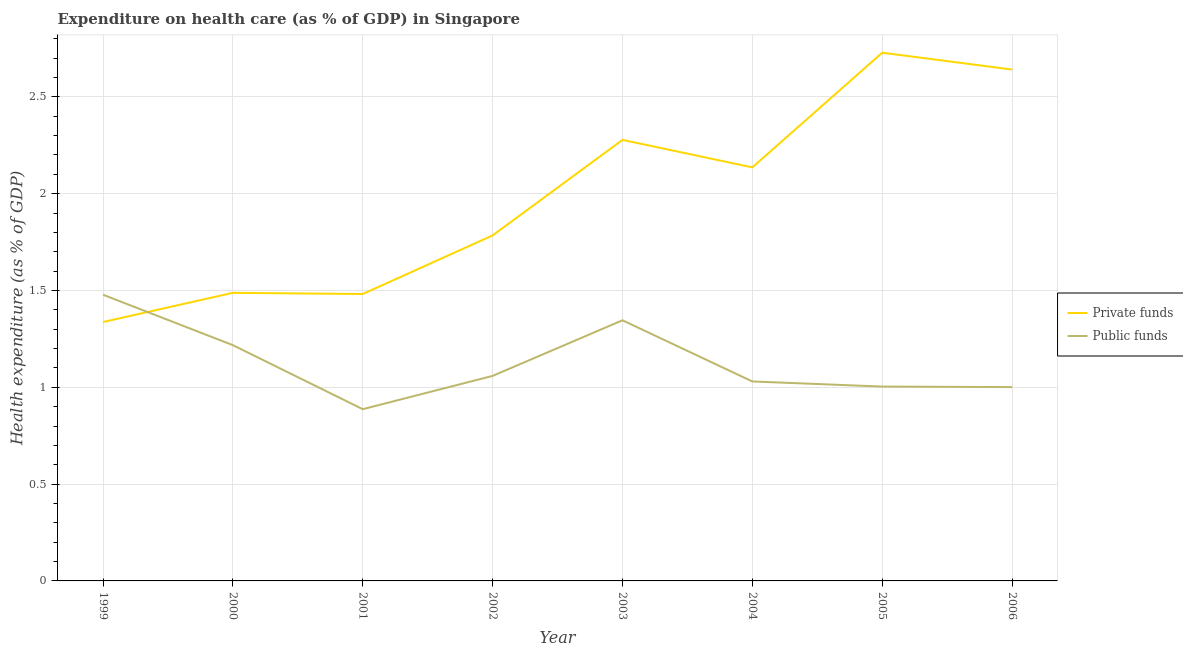How many different coloured lines are there?
Ensure brevity in your answer.  2. What is the amount of private funds spent in healthcare in 2000?
Ensure brevity in your answer.  1.49. Across all years, what is the maximum amount of public funds spent in healthcare?
Ensure brevity in your answer.  1.48. Across all years, what is the minimum amount of private funds spent in healthcare?
Your answer should be compact. 1.34. In which year was the amount of private funds spent in healthcare maximum?
Offer a terse response. 2005. What is the total amount of private funds spent in healthcare in the graph?
Offer a very short reply. 15.87. What is the difference between the amount of private funds spent in healthcare in 2002 and that in 2004?
Offer a terse response. -0.35. What is the difference between the amount of public funds spent in healthcare in 2000 and the amount of private funds spent in healthcare in 2005?
Keep it short and to the point. -1.51. What is the average amount of public funds spent in healthcare per year?
Give a very brief answer. 1.13. In the year 2000, what is the difference between the amount of private funds spent in healthcare and amount of public funds spent in healthcare?
Your answer should be compact. 0.27. In how many years, is the amount of private funds spent in healthcare greater than 2.2 %?
Your response must be concise. 3. What is the ratio of the amount of public funds spent in healthcare in 2000 to that in 2003?
Keep it short and to the point. 0.9. What is the difference between the highest and the second highest amount of private funds spent in healthcare?
Provide a succinct answer. 0.09. What is the difference between the highest and the lowest amount of public funds spent in healthcare?
Provide a short and direct response. 0.59. In how many years, is the amount of private funds spent in healthcare greater than the average amount of private funds spent in healthcare taken over all years?
Provide a short and direct response. 4. Is the sum of the amount of private funds spent in healthcare in 2000 and 2001 greater than the maximum amount of public funds spent in healthcare across all years?
Provide a short and direct response. Yes. Is the amount of public funds spent in healthcare strictly greater than the amount of private funds spent in healthcare over the years?
Keep it short and to the point. No. How many years are there in the graph?
Provide a succinct answer. 8. What is the difference between two consecutive major ticks on the Y-axis?
Your answer should be compact. 0.5. Does the graph contain any zero values?
Keep it short and to the point. No. Where does the legend appear in the graph?
Offer a very short reply. Center right. How many legend labels are there?
Your answer should be very brief. 2. What is the title of the graph?
Provide a short and direct response. Expenditure on health care (as % of GDP) in Singapore. Does "Crop" appear as one of the legend labels in the graph?
Ensure brevity in your answer.  No. What is the label or title of the Y-axis?
Give a very brief answer. Health expenditure (as % of GDP). What is the Health expenditure (as % of GDP) in Private funds in 1999?
Keep it short and to the point. 1.34. What is the Health expenditure (as % of GDP) of Public funds in 1999?
Your response must be concise. 1.48. What is the Health expenditure (as % of GDP) in Private funds in 2000?
Your answer should be very brief. 1.49. What is the Health expenditure (as % of GDP) of Public funds in 2000?
Make the answer very short. 1.22. What is the Health expenditure (as % of GDP) in Private funds in 2001?
Your answer should be very brief. 1.48. What is the Health expenditure (as % of GDP) in Public funds in 2001?
Give a very brief answer. 0.89. What is the Health expenditure (as % of GDP) in Private funds in 2002?
Make the answer very short. 1.78. What is the Health expenditure (as % of GDP) in Public funds in 2002?
Your answer should be very brief. 1.06. What is the Health expenditure (as % of GDP) in Private funds in 2003?
Give a very brief answer. 2.28. What is the Health expenditure (as % of GDP) in Public funds in 2003?
Provide a short and direct response. 1.35. What is the Health expenditure (as % of GDP) of Private funds in 2004?
Keep it short and to the point. 2.14. What is the Health expenditure (as % of GDP) of Public funds in 2004?
Your response must be concise. 1.03. What is the Health expenditure (as % of GDP) in Private funds in 2005?
Your answer should be very brief. 2.73. What is the Health expenditure (as % of GDP) of Public funds in 2005?
Your answer should be compact. 1. What is the Health expenditure (as % of GDP) in Private funds in 2006?
Offer a very short reply. 2.64. What is the Health expenditure (as % of GDP) in Public funds in 2006?
Offer a terse response. 1. Across all years, what is the maximum Health expenditure (as % of GDP) in Private funds?
Provide a short and direct response. 2.73. Across all years, what is the maximum Health expenditure (as % of GDP) of Public funds?
Your answer should be compact. 1.48. Across all years, what is the minimum Health expenditure (as % of GDP) in Private funds?
Keep it short and to the point. 1.34. Across all years, what is the minimum Health expenditure (as % of GDP) in Public funds?
Make the answer very short. 0.89. What is the total Health expenditure (as % of GDP) of Private funds in the graph?
Your answer should be very brief. 15.87. What is the total Health expenditure (as % of GDP) of Public funds in the graph?
Your answer should be very brief. 9.02. What is the difference between the Health expenditure (as % of GDP) of Private funds in 1999 and that in 2000?
Your response must be concise. -0.15. What is the difference between the Health expenditure (as % of GDP) in Public funds in 1999 and that in 2000?
Keep it short and to the point. 0.26. What is the difference between the Health expenditure (as % of GDP) of Private funds in 1999 and that in 2001?
Provide a succinct answer. -0.14. What is the difference between the Health expenditure (as % of GDP) in Public funds in 1999 and that in 2001?
Provide a short and direct response. 0.59. What is the difference between the Health expenditure (as % of GDP) of Private funds in 1999 and that in 2002?
Your response must be concise. -0.45. What is the difference between the Health expenditure (as % of GDP) of Public funds in 1999 and that in 2002?
Keep it short and to the point. 0.42. What is the difference between the Health expenditure (as % of GDP) in Private funds in 1999 and that in 2003?
Provide a short and direct response. -0.94. What is the difference between the Health expenditure (as % of GDP) in Public funds in 1999 and that in 2003?
Ensure brevity in your answer.  0.13. What is the difference between the Health expenditure (as % of GDP) in Private funds in 1999 and that in 2004?
Provide a short and direct response. -0.8. What is the difference between the Health expenditure (as % of GDP) in Public funds in 1999 and that in 2004?
Keep it short and to the point. 0.45. What is the difference between the Health expenditure (as % of GDP) of Private funds in 1999 and that in 2005?
Provide a succinct answer. -1.39. What is the difference between the Health expenditure (as % of GDP) in Public funds in 1999 and that in 2005?
Make the answer very short. 0.47. What is the difference between the Health expenditure (as % of GDP) of Private funds in 1999 and that in 2006?
Your answer should be compact. -1.3. What is the difference between the Health expenditure (as % of GDP) of Public funds in 1999 and that in 2006?
Provide a succinct answer. 0.48. What is the difference between the Health expenditure (as % of GDP) in Private funds in 2000 and that in 2001?
Provide a succinct answer. 0.01. What is the difference between the Health expenditure (as % of GDP) in Public funds in 2000 and that in 2001?
Provide a short and direct response. 0.33. What is the difference between the Health expenditure (as % of GDP) of Private funds in 2000 and that in 2002?
Offer a terse response. -0.3. What is the difference between the Health expenditure (as % of GDP) of Public funds in 2000 and that in 2002?
Offer a very short reply. 0.16. What is the difference between the Health expenditure (as % of GDP) of Private funds in 2000 and that in 2003?
Your answer should be very brief. -0.79. What is the difference between the Health expenditure (as % of GDP) of Public funds in 2000 and that in 2003?
Make the answer very short. -0.13. What is the difference between the Health expenditure (as % of GDP) of Private funds in 2000 and that in 2004?
Ensure brevity in your answer.  -0.65. What is the difference between the Health expenditure (as % of GDP) in Public funds in 2000 and that in 2004?
Your response must be concise. 0.19. What is the difference between the Health expenditure (as % of GDP) of Private funds in 2000 and that in 2005?
Give a very brief answer. -1.24. What is the difference between the Health expenditure (as % of GDP) in Public funds in 2000 and that in 2005?
Ensure brevity in your answer.  0.21. What is the difference between the Health expenditure (as % of GDP) in Private funds in 2000 and that in 2006?
Ensure brevity in your answer.  -1.15. What is the difference between the Health expenditure (as % of GDP) of Public funds in 2000 and that in 2006?
Your answer should be very brief. 0.22. What is the difference between the Health expenditure (as % of GDP) of Private funds in 2001 and that in 2002?
Provide a short and direct response. -0.3. What is the difference between the Health expenditure (as % of GDP) of Public funds in 2001 and that in 2002?
Provide a succinct answer. -0.17. What is the difference between the Health expenditure (as % of GDP) of Private funds in 2001 and that in 2003?
Your answer should be compact. -0.8. What is the difference between the Health expenditure (as % of GDP) in Public funds in 2001 and that in 2003?
Offer a very short reply. -0.46. What is the difference between the Health expenditure (as % of GDP) of Private funds in 2001 and that in 2004?
Your response must be concise. -0.65. What is the difference between the Health expenditure (as % of GDP) in Public funds in 2001 and that in 2004?
Give a very brief answer. -0.14. What is the difference between the Health expenditure (as % of GDP) of Private funds in 2001 and that in 2005?
Provide a short and direct response. -1.25. What is the difference between the Health expenditure (as % of GDP) in Public funds in 2001 and that in 2005?
Offer a very short reply. -0.12. What is the difference between the Health expenditure (as % of GDP) of Private funds in 2001 and that in 2006?
Your answer should be compact. -1.16. What is the difference between the Health expenditure (as % of GDP) in Public funds in 2001 and that in 2006?
Keep it short and to the point. -0.11. What is the difference between the Health expenditure (as % of GDP) of Private funds in 2002 and that in 2003?
Provide a short and direct response. -0.49. What is the difference between the Health expenditure (as % of GDP) of Public funds in 2002 and that in 2003?
Your answer should be compact. -0.29. What is the difference between the Health expenditure (as % of GDP) in Private funds in 2002 and that in 2004?
Your answer should be compact. -0.35. What is the difference between the Health expenditure (as % of GDP) in Public funds in 2002 and that in 2004?
Give a very brief answer. 0.03. What is the difference between the Health expenditure (as % of GDP) of Private funds in 2002 and that in 2005?
Provide a short and direct response. -0.94. What is the difference between the Health expenditure (as % of GDP) in Public funds in 2002 and that in 2005?
Offer a very short reply. 0.06. What is the difference between the Health expenditure (as % of GDP) in Private funds in 2002 and that in 2006?
Your answer should be compact. -0.86. What is the difference between the Health expenditure (as % of GDP) in Public funds in 2002 and that in 2006?
Offer a very short reply. 0.06. What is the difference between the Health expenditure (as % of GDP) of Private funds in 2003 and that in 2004?
Provide a succinct answer. 0.14. What is the difference between the Health expenditure (as % of GDP) in Public funds in 2003 and that in 2004?
Provide a short and direct response. 0.32. What is the difference between the Health expenditure (as % of GDP) in Private funds in 2003 and that in 2005?
Your answer should be very brief. -0.45. What is the difference between the Health expenditure (as % of GDP) of Public funds in 2003 and that in 2005?
Your answer should be very brief. 0.34. What is the difference between the Health expenditure (as % of GDP) of Private funds in 2003 and that in 2006?
Keep it short and to the point. -0.36. What is the difference between the Health expenditure (as % of GDP) in Public funds in 2003 and that in 2006?
Offer a terse response. 0.35. What is the difference between the Health expenditure (as % of GDP) in Private funds in 2004 and that in 2005?
Provide a succinct answer. -0.59. What is the difference between the Health expenditure (as % of GDP) of Public funds in 2004 and that in 2005?
Ensure brevity in your answer.  0.03. What is the difference between the Health expenditure (as % of GDP) of Private funds in 2004 and that in 2006?
Ensure brevity in your answer.  -0.51. What is the difference between the Health expenditure (as % of GDP) of Public funds in 2004 and that in 2006?
Offer a terse response. 0.03. What is the difference between the Health expenditure (as % of GDP) of Private funds in 2005 and that in 2006?
Your response must be concise. 0.09. What is the difference between the Health expenditure (as % of GDP) of Public funds in 2005 and that in 2006?
Make the answer very short. 0. What is the difference between the Health expenditure (as % of GDP) of Private funds in 1999 and the Health expenditure (as % of GDP) of Public funds in 2000?
Keep it short and to the point. 0.12. What is the difference between the Health expenditure (as % of GDP) in Private funds in 1999 and the Health expenditure (as % of GDP) in Public funds in 2001?
Your response must be concise. 0.45. What is the difference between the Health expenditure (as % of GDP) of Private funds in 1999 and the Health expenditure (as % of GDP) of Public funds in 2002?
Offer a terse response. 0.28. What is the difference between the Health expenditure (as % of GDP) of Private funds in 1999 and the Health expenditure (as % of GDP) of Public funds in 2003?
Provide a short and direct response. -0.01. What is the difference between the Health expenditure (as % of GDP) in Private funds in 1999 and the Health expenditure (as % of GDP) in Public funds in 2004?
Provide a succinct answer. 0.31. What is the difference between the Health expenditure (as % of GDP) in Private funds in 1999 and the Health expenditure (as % of GDP) in Public funds in 2005?
Provide a short and direct response. 0.33. What is the difference between the Health expenditure (as % of GDP) of Private funds in 1999 and the Health expenditure (as % of GDP) of Public funds in 2006?
Provide a succinct answer. 0.34. What is the difference between the Health expenditure (as % of GDP) in Private funds in 2000 and the Health expenditure (as % of GDP) in Public funds in 2001?
Your response must be concise. 0.6. What is the difference between the Health expenditure (as % of GDP) in Private funds in 2000 and the Health expenditure (as % of GDP) in Public funds in 2002?
Provide a short and direct response. 0.43. What is the difference between the Health expenditure (as % of GDP) of Private funds in 2000 and the Health expenditure (as % of GDP) of Public funds in 2003?
Your answer should be very brief. 0.14. What is the difference between the Health expenditure (as % of GDP) of Private funds in 2000 and the Health expenditure (as % of GDP) of Public funds in 2004?
Your answer should be compact. 0.46. What is the difference between the Health expenditure (as % of GDP) in Private funds in 2000 and the Health expenditure (as % of GDP) in Public funds in 2005?
Provide a succinct answer. 0.48. What is the difference between the Health expenditure (as % of GDP) of Private funds in 2000 and the Health expenditure (as % of GDP) of Public funds in 2006?
Provide a succinct answer. 0.49. What is the difference between the Health expenditure (as % of GDP) in Private funds in 2001 and the Health expenditure (as % of GDP) in Public funds in 2002?
Your answer should be very brief. 0.42. What is the difference between the Health expenditure (as % of GDP) in Private funds in 2001 and the Health expenditure (as % of GDP) in Public funds in 2003?
Offer a terse response. 0.14. What is the difference between the Health expenditure (as % of GDP) in Private funds in 2001 and the Health expenditure (as % of GDP) in Public funds in 2004?
Your answer should be very brief. 0.45. What is the difference between the Health expenditure (as % of GDP) in Private funds in 2001 and the Health expenditure (as % of GDP) in Public funds in 2005?
Your answer should be compact. 0.48. What is the difference between the Health expenditure (as % of GDP) in Private funds in 2001 and the Health expenditure (as % of GDP) in Public funds in 2006?
Offer a very short reply. 0.48. What is the difference between the Health expenditure (as % of GDP) in Private funds in 2002 and the Health expenditure (as % of GDP) in Public funds in 2003?
Ensure brevity in your answer.  0.44. What is the difference between the Health expenditure (as % of GDP) of Private funds in 2002 and the Health expenditure (as % of GDP) of Public funds in 2004?
Keep it short and to the point. 0.75. What is the difference between the Health expenditure (as % of GDP) of Private funds in 2002 and the Health expenditure (as % of GDP) of Public funds in 2005?
Offer a terse response. 0.78. What is the difference between the Health expenditure (as % of GDP) of Private funds in 2002 and the Health expenditure (as % of GDP) of Public funds in 2006?
Your answer should be compact. 0.78. What is the difference between the Health expenditure (as % of GDP) of Private funds in 2003 and the Health expenditure (as % of GDP) of Public funds in 2004?
Provide a succinct answer. 1.25. What is the difference between the Health expenditure (as % of GDP) of Private funds in 2003 and the Health expenditure (as % of GDP) of Public funds in 2005?
Ensure brevity in your answer.  1.27. What is the difference between the Health expenditure (as % of GDP) of Private funds in 2003 and the Health expenditure (as % of GDP) of Public funds in 2006?
Ensure brevity in your answer.  1.28. What is the difference between the Health expenditure (as % of GDP) of Private funds in 2004 and the Health expenditure (as % of GDP) of Public funds in 2005?
Your answer should be compact. 1.13. What is the difference between the Health expenditure (as % of GDP) of Private funds in 2004 and the Health expenditure (as % of GDP) of Public funds in 2006?
Your answer should be compact. 1.13. What is the difference between the Health expenditure (as % of GDP) of Private funds in 2005 and the Health expenditure (as % of GDP) of Public funds in 2006?
Make the answer very short. 1.73. What is the average Health expenditure (as % of GDP) of Private funds per year?
Offer a very short reply. 1.98. What is the average Health expenditure (as % of GDP) of Public funds per year?
Your answer should be compact. 1.13. In the year 1999, what is the difference between the Health expenditure (as % of GDP) of Private funds and Health expenditure (as % of GDP) of Public funds?
Keep it short and to the point. -0.14. In the year 2000, what is the difference between the Health expenditure (as % of GDP) in Private funds and Health expenditure (as % of GDP) in Public funds?
Your response must be concise. 0.27. In the year 2001, what is the difference between the Health expenditure (as % of GDP) in Private funds and Health expenditure (as % of GDP) in Public funds?
Keep it short and to the point. 0.59. In the year 2002, what is the difference between the Health expenditure (as % of GDP) in Private funds and Health expenditure (as % of GDP) in Public funds?
Offer a very short reply. 0.73. In the year 2003, what is the difference between the Health expenditure (as % of GDP) in Private funds and Health expenditure (as % of GDP) in Public funds?
Your answer should be very brief. 0.93. In the year 2004, what is the difference between the Health expenditure (as % of GDP) in Private funds and Health expenditure (as % of GDP) in Public funds?
Your response must be concise. 1.11. In the year 2005, what is the difference between the Health expenditure (as % of GDP) in Private funds and Health expenditure (as % of GDP) in Public funds?
Keep it short and to the point. 1.72. In the year 2006, what is the difference between the Health expenditure (as % of GDP) of Private funds and Health expenditure (as % of GDP) of Public funds?
Give a very brief answer. 1.64. What is the ratio of the Health expenditure (as % of GDP) of Private funds in 1999 to that in 2000?
Keep it short and to the point. 0.9. What is the ratio of the Health expenditure (as % of GDP) in Public funds in 1999 to that in 2000?
Make the answer very short. 1.21. What is the ratio of the Health expenditure (as % of GDP) of Private funds in 1999 to that in 2001?
Provide a succinct answer. 0.9. What is the ratio of the Health expenditure (as % of GDP) of Public funds in 1999 to that in 2001?
Keep it short and to the point. 1.67. What is the ratio of the Health expenditure (as % of GDP) of Private funds in 1999 to that in 2002?
Your answer should be very brief. 0.75. What is the ratio of the Health expenditure (as % of GDP) in Public funds in 1999 to that in 2002?
Offer a terse response. 1.4. What is the ratio of the Health expenditure (as % of GDP) in Private funds in 1999 to that in 2003?
Keep it short and to the point. 0.59. What is the ratio of the Health expenditure (as % of GDP) of Public funds in 1999 to that in 2003?
Your answer should be compact. 1.1. What is the ratio of the Health expenditure (as % of GDP) in Private funds in 1999 to that in 2004?
Give a very brief answer. 0.63. What is the ratio of the Health expenditure (as % of GDP) of Public funds in 1999 to that in 2004?
Your answer should be very brief. 1.43. What is the ratio of the Health expenditure (as % of GDP) of Private funds in 1999 to that in 2005?
Make the answer very short. 0.49. What is the ratio of the Health expenditure (as % of GDP) in Public funds in 1999 to that in 2005?
Offer a very short reply. 1.47. What is the ratio of the Health expenditure (as % of GDP) of Private funds in 1999 to that in 2006?
Ensure brevity in your answer.  0.51. What is the ratio of the Health expenditure (as % of GDP) of Public funds in 1999 to that in 2006?
Offer a terse response. 1.48. What is the ratio of the Health expenditure (as % of GDP) in Public funds in 2000 to that in 2001?
Ensure brevity in your answer.  1.37. What is the ratio of the Health expenditure (as % of GDP) in Private funds in 2000 to that in 2002?
Provide a succinct answer. 0.83. What is the ratio of the Health expenditure (as % of GDP) of Public funds in 2000 to that in 2002?
Your answer should be compact. 1.15. What is the ratio of the Health expenditure (as % of GDP) in Private funds in 2000 to that in 2003?
Your answer should be compact. 0.65. What is the ratio of the Health expenditure (as % of GDP) in Public funds in 2000 to that in 2003?
Offer a very short reply. 0.9. What is the ratio of the Health expenditure (as % of GDP) in Private funds in 2000 to that in 2004?
Offer a terse response. 0.7. What is the ratio of the Health expenditure (as % of GDP) of Public funds in 2000 to that in 2004?
Give a very brief answer. 1.18. What is the ratio of the Health expenditure (as % of GDP) of Private funds in 2000 to that in 2005?
Keep it short and to the point. 0.55. What is the ratio of the Health expenditure (as % of GDP) of Public funds in 2000 to that in 2005?
Offer a very short reply. 1.21. What is the ratio of the Health expenditure (as % of GDP) in Private funds in 2000 to that in 2006?
Give a very brief answer. 0.56. What is the ratio of the Health expenditure (as % of GDP) in Public funds in 2000 to that in 2006?
Your answer should be very brief. 1.22. What is the ratio of the Health expenditure (as % of GDP) in Private funds in 2001 to that in 2002?
Offer a terse response. 0.83. What is the ratio of the Health expenditure (as % of GDP) of Public funds in 2001 to that in 2002?
Ensure brevity in your answer.  0.84. What is the ratio of the Health expenditure (as % of GDP) in Private funds in 2001 to that in 2003?
Offer a terse response. 0.65. What is the ratio of the Health expenditure (as % of GDP) in Public funds in 2001 to that in 2003?
Provide a succinct answer. 0.66. What is the ratio of the Health expenditure (as % of GDP) in Private funds in 2001 to that in 2004?
Your answer should be compact. 0.69. What is the ratio of the Health expenditure (as % of GDP) of Public funds in 2001 to that in 2004?
Your response must be concise. 0.86. What is the ratio of the Health expenditure (as % of GDP) in Private funds in 2001 to that in 2005?
Your answer should be compact. 0.54. What is the ratio of the Health expenditure (as % of GDP) in Public funds in 2001 to that in 2005?
Provide a succinct answer. 0.88. What is the ratio of the Health expenditure (as % of GDP) of Private funds in 2001 to that in 2006?
Your answer should be very brief. 0.56. What is the ratio of the Health expenditure (as % of GDP) in Public funds in 2001 to that in 2006?
Keep it short and to the point. 0.89. What is the ratio of the Health expenditure (as % of GDP) in Private funds in 2002 to that in 2003?
Your response must be concise. 0.78. What is the ratio of the Health expenditure (as % of GDP) of Public funds in 2002 to that in 2003?
Your answer should be very brief. 0.79. What is the ratio of the Health expenditure (as % of GDP) of Private funds in 2002 to that in 2004?
Your answer should be compact. 0.84. What is the ratio of the Health expenditure (as % of GDP) in Public funds in 2002 to that in 2004?
Ensure brevity in your answer.  1.03. What is the ratio of the Health expenditure (as % of GDP) in Private funds in 2002 to that in 2005?
Your response must be concise. 0.65. What is the ratio of the Health expenditure (as % of GDP) in Public funds in 2002 to that in 2005?
Offer a very short reply. 1.05. What is the ratio of the Health expenditure (as % of GDP) in Private funds in 2002 to that in 2006?
Keep it short and to the point. 0.68. What is the ratio of the Health expenditure (as % of GDP) in Public funds in 2002 to that in 2006?
Provide a short and direct response. 1.06. What is the ratio of the Health expenditure (as % of GDP) of Private funds in 2003 to that in 2004?
Offer a very short reply. 1.07. What is the ratio of the Health expenditure (as % of GDP) in Public funds in 2003 to that in 2004?
Provide a short and direct response. 1.31. What is the ratio of the Health expenditure (as % of GDP) in Private funds in 2003 to that in 2005?
Your answer should be compact. 0.83. What is the ratio of the Health expenditure (as % of GDP) of Public funds in 2003 to that in 2005?
Offer a terse response. 1.34. What is the ratio of the Health expenditure (as % of GDP) of Private funds in 2003 to that in 2006?
Your answer should be compact. 0.86. What is the ratio of the Health expenditure (as % of GDP) in Public funds in 2003 to that in 2006?
Provide a short and direct response. 1.34. What is the ratio of the Health expenditure (as % of GDP) of Private funds in 2004 to that in 2005?
Ensure brevity in your answer.  0.78. What is the ratio of the Health expenditure (as % of GDP) in Public funds in 2004 to that in 2005?
Your answer should be compact. 1.03. What is the ratio of the Health expenditure (as % of GDP) in Private funds in 2004 to that in 2006?
Keep it short and to the point. 0.81. What is the ratio of the Health expenditure (as % of GDP) of Public funds in 2004 to that in 2006?
Make the answer very short. 1.03. What is the ratio of the Health expenditure (as % of GDP) in Private funds in 2005 to that in 2006?
Offer a terse response. 1.03. What is the difference between the highest and the second highest Health expenditure (as % of GDP) of Private funds?
Your answer should be very brief. 0.09. What is the difference between the highest and the second highest Health expenditure (as % of GDP) in Public funds?
Your answer should be very brief. 0.13. What is the difference between the highest and the lowest Health expenditure (as % of GDP) in Private funds?
Give a very brief answer. 1.39. What is the difference between the highest and the lowest Health expenditure (as % of GDP) in Public funds?
Your answer should be compact. 0.59. 